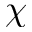<formula> <loc_0><loc_0><loc_500><loc_500>\chi</formula> 